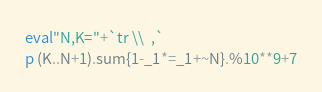Convert code to text. <code><loc_0><loc_0><loc_500><loc_500><_Ruby_>eval"N,K="+`tr \\  ,`
p (K..N+1).sum{1-_1*=_1+~N}.%10**9+7</code> 